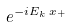<formula> <loc_0><loc_0><loc_500><loc_500>e ^ { - i E _ { k } \, x _ { + } }</formula> 